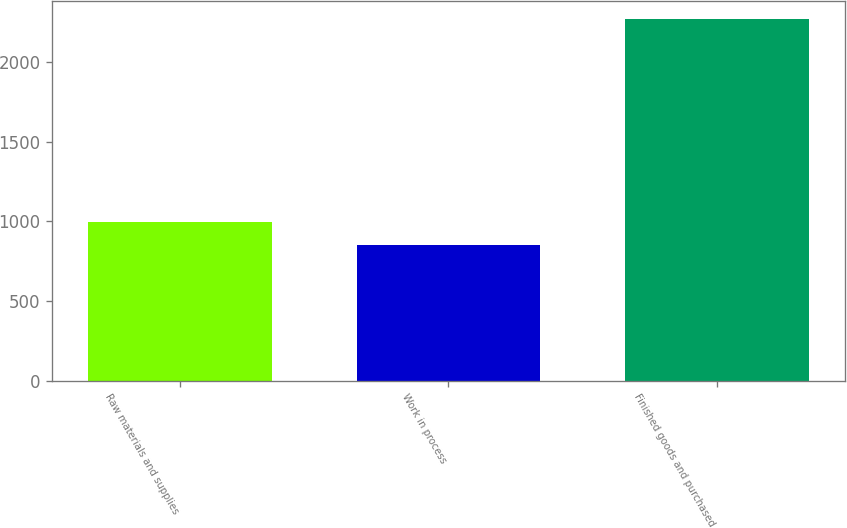<chart> <loc_0><loc_0><loc_500><loc_500><bar_chart><fcel>Raw materials and supplies<fcel>Work in process<fcel>Finished goods and purchased<nl><fcel>993.9<fcel>852<fcel>2271<nl></chart> 